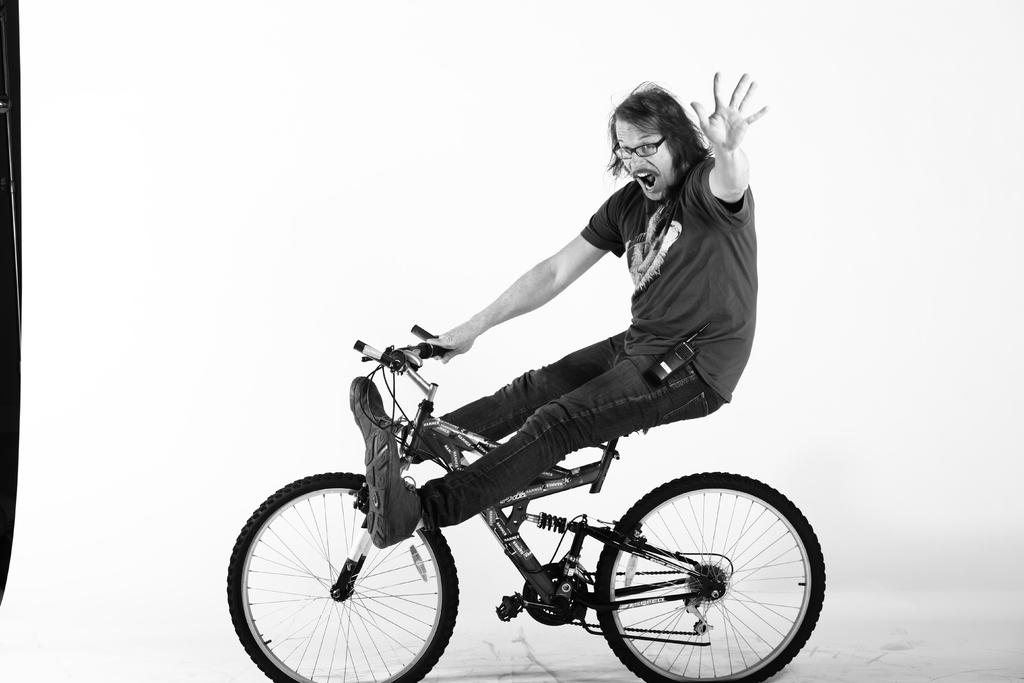What can be seen in the image? There are men in the image. What are the men wearing? The men are wearing spectacles. What are the men holding in their hands? The men are holding bicycles in their hands. What are the men doing in the image? The men are shouting. What is the color of the background in the image? The background of the image is white in color. What type of lace can be seen on the floor in the image? There is no lace present on the floor in the image. What news event is being discussed by the men in the image? There is no indication of a news event being discussed in the image; the men are simply shouting. 